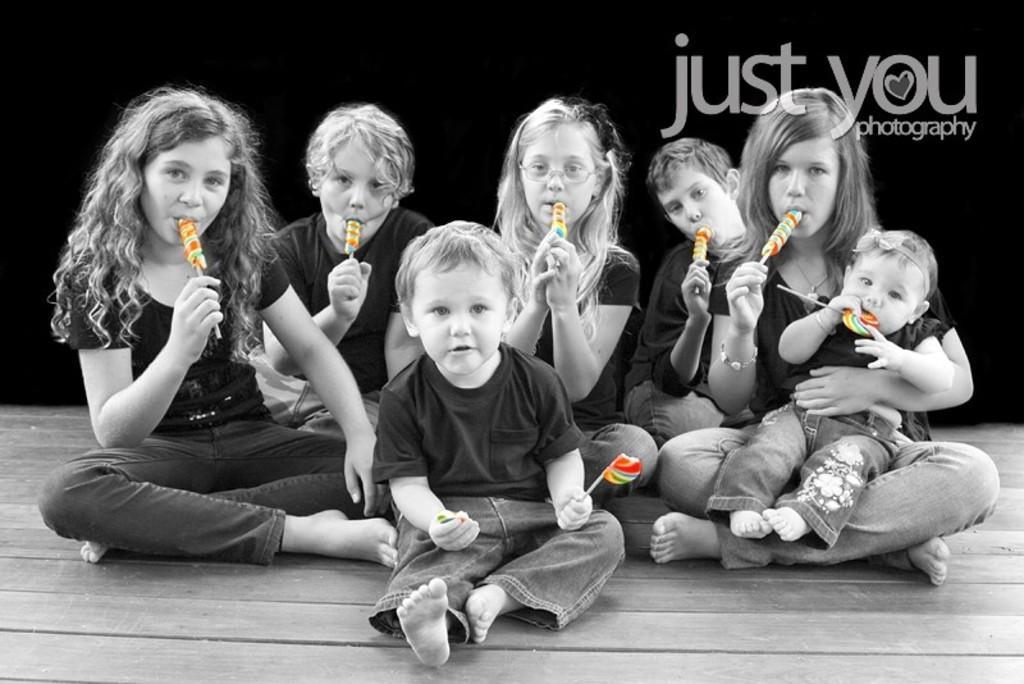In one or two sentences, can you explain what this image depicts? As we can see in the image there are group of people wearing black color t shirts and holding lollipops. Behind them there is a banner. 